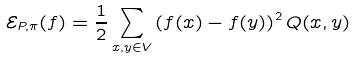<formula> <loc_0><loc_0><loc_500><loc_500>\mathcal { E } _ { P , \pi } ( f ) = \frac { 1 } { 2 } \sum _ { x , y \in V } \left ( f ( x ) - f ( y ) \right ) ^ { 2 } Q ( x , y )</formula> 